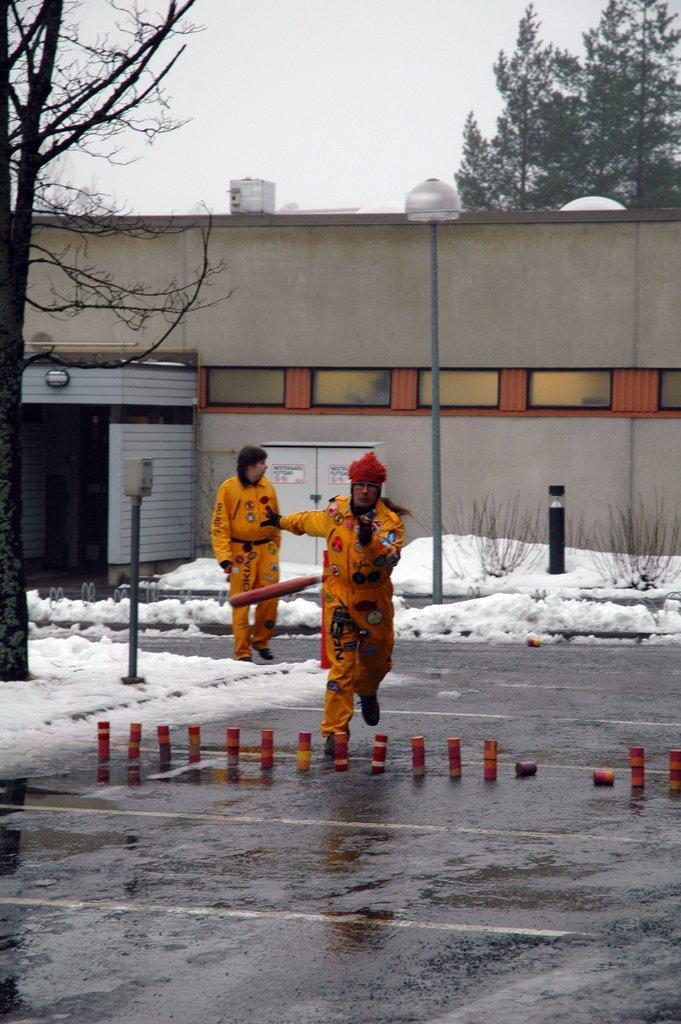Please provide a concise description of this image. In this image there is a lady running, there are few objects placed on the road, behind her there is another lady standing. On the left side of the image there is a tree and there is snow on the road. In the background there is a building, trees and the sky. 